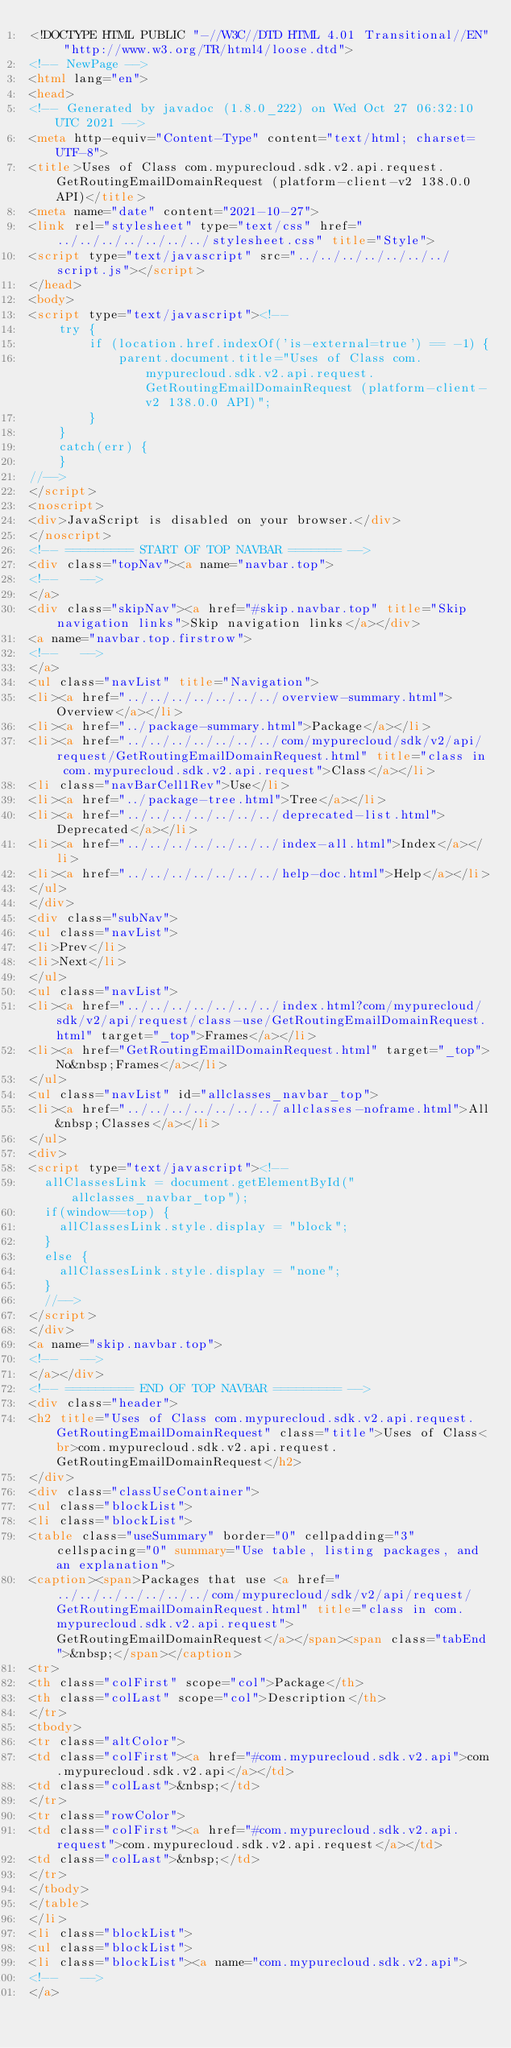<code> <loc_0><loc_0><loc_500><loc_500><_HTML_><!DOCTYPE HTML PUBLIC "-//W3C//DTD HTML 4.01 Transitional//EN" "http://www.w3.org/TR/html4/loose.dtd">
<!-- NewPage -->
<html lang="en">
<head>
<!-- Generated by javadoc (1.8.0_222) on Wed Oct 27 06:32:10 UTC 2021 -->
<meta http-equiv="Content-Type" content="text/html; charset=UTF-8">
<title>Uses of Class com.mypurecloud.sdk.v2.api.request.GetRoutingEmailDomainRequest (platform-client-v2 138.0.0 API)</title>
<meta name="date" content="2021-10-27">
<link rel="stylesheet" type="text/css" href="../../../../../../../stylesheet.css" title="Style">
<script type="text/javascript" src="../../../../../../../script.js"></script>
</head>
<body>
<script type="text/javascript"><!--
    try {
        if (location.href.indexOf('is-external=true') == -1) {
            parent.document.title="Uses of Class com.mypurecloud.sdk.v2.api.request.GetRoutingEmailDomainRequest (platform-client-v2 138.0.0 API)";
        }
    }
    catch(err) {
    }
//-->
</script>
<noscript>
<div>JavaScript is disabled on your browser.</div>
</noscript>
<!-- ========= START OF TOP NAVBAR ======= -->
<div class="topNav"><a name="navbar.top">
<!--   -->
</a>
<div class="skipNav"><a href="#skip.navbar.top" title="Skip navigation links">Skip navigation links</a></div>
<a name="navbar.top.firstrow">
<!--   -->
</a>
<ul class="navList" title="Navigation">
<li><a href="../../../../../../../overview-summary.html">Overview</a></li>
<li><a href="../package-summary.html">Package</a></li>
<li><a href="../../../../../../../com/mypurecloud/sdk/v2/api/request/GetRoutingEmailDomainRequest.html" title="class in com.mypurecloud.sdk.v2.api.request">Class</a></li>
<li class="navBarCell1Rev">Use</li>
<li><a href="../package-tree.html">Tree</a></li>
<li><a href="../../../../../../../deprecated-list.html">Deprecated</a></li>
<li><a href="../../../../../../../index-all.html">Index</a></li>
<li><a href="../../../../../../../help-doc.html">Help</a></li>
</ul>
</div>
<div class="subNav">
<ul class="navList">
<li>Prev</li>
<li>Next</li>
</ul>
<ul class="navList">
<li><a href="../../../../../../../index.html?com/mypurecloud/sdk/v2/api/request/class-use/GetRoutingEmailDomainRequest.html" target="_top">Frames</a></li>
<li><a href="GetRoutingEmailDomainRequest.html" target="_top">No&nbsp;Frames</a></li>
</ul>
<ul class="navList" id="allclasses_navbar_top">
<li><a href="../../../../../../../allclasses-noframe.html">All&nbsp;Classes</a></li>
</ul>
<div>
<script type="text/javascript"><!--
  allClassesLink = document.getElementById("allclasses_navbar_top");
  if(window==top) {
    allClassesLink.style.display = "block";
  }
  else {
    allClassesLink.style.display = "none";
  }
  //-->
</script>
</div>
<a name="skip.navbar.top">
<!--   -->
</a></div>
<!-- ========= END OF TOP NAVBAR ========= -->
<div class="header">
<h2 title="Uses of Class com.mypurecloud.sdk.v2.api.request.GetRoutingEmailDomainRequest" class="title">Uses of Class<br>com.mypurecloud.sdk.v2.api.request.GetRoutingEmailDomainRequest</h2>
</div>
<div class="classUseContainer">
<ul class="blockList">
<li class="blockList">
<table class="useSummary" border="0" cellpadding="3" cellspacing="0" summary="Use table, listing packages, and an explanation">
<caption><span>Packages that use <a href="../../../../../../../com/mypurecloud/sdk/v2/api/request/GetRoutingEmailDomainRequest.html" title="class in com.mypurecloud.sdk.v2.api.request">GetRoutingEmailDomainRequest</a></span><span class="tabEnd">&nbsp;</span></caption>
<tr>
<th class="colFirst" scope="col">Package</th>
<th class="colLast" scope="col">Description</th>
</tr>
<tbody>
<tr class="altColor">
<td class="colFirst"><a href="#com.mypurecloud.sdk.v2.api">com.mypurecloud.sdk.v2.api</a></td>
<td class="colLast">&nbsp;</td>
</tr>
<tr class="rowColor">
<td class="colFirst"><a href="#com.mypurecloud.sdk.v2.api.request">com.mypurecloud.sdk.v2.api.request</a></td>
<td class="colLast">&nbsp;</td>
</tr>
</tbody>
</table>
</li>
<li class="blockList">
<ul class="blockList">
<li class="blockList"><a name="com.mypurecloud.sdk.v2.api">
<!--   -->
</a></code> 